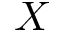Convert formula to latex. <formula><loc_0><loc_0><loc_500><loc_500>X</formula> 